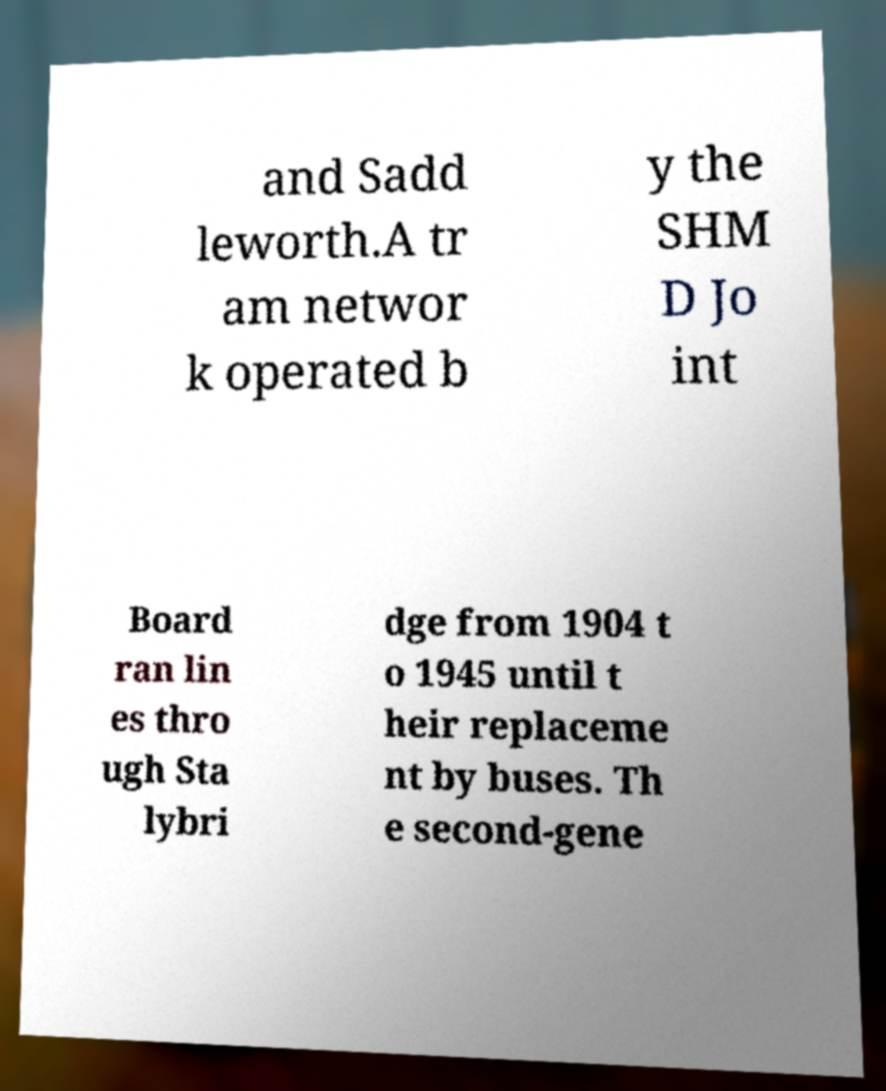What messages or text are displayed in this image? I need them in a readable, typed format. and Sadd leworth.A tr am networ k operated b y the SHM D Jo int Board ran lin es thro ugh Sta lybri dge from 1904 t o 1945 until t heir replaceme nt by buses. Th e second-gene 